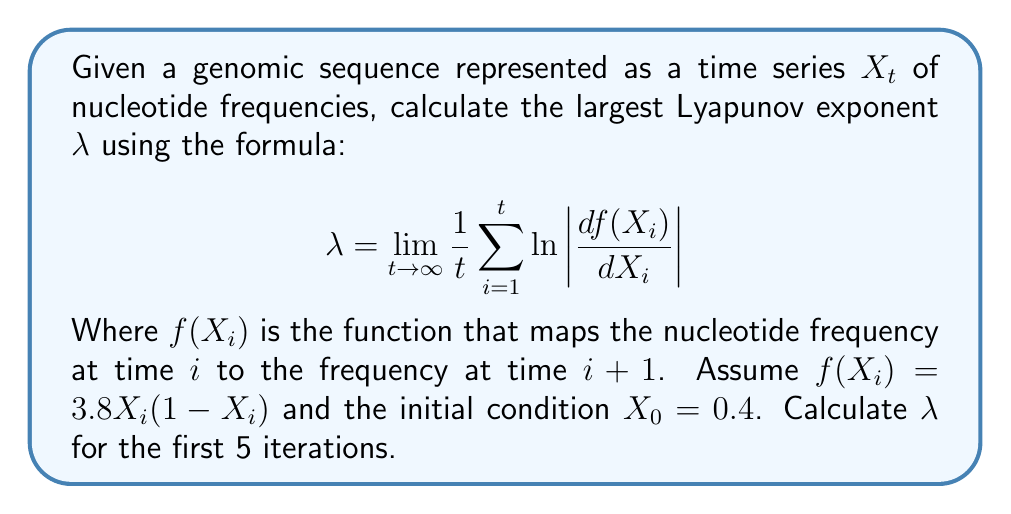Can you solve this math problem? To calculate the largest Lyapunov exponent $\lambda$ for the given genomic sequence data, we'll follow these steps:

1) First, we need to calculate $X_i$ for $i = 1$ to $5$ using the given function $f(X_i) = 3.8X_i(1-X_i)$ and initial condition $X_0 = 0.4$:

   $X_1 = f(X_0) = 3.8 \cdot 0.4 \cdot (1-0.4) = 0.912$
   $X_2 = f(X_1) = 3.8 \cdot 0.912 \cdot (1-0.912) = 0.305472$
   $X_3 = f(X_2) = 3.8 \cdot 0.305472 \cdot (1-0.305472) = 0.806219$
   $X_4 = f(X_3) = 3.8 \cdot 0.806219 \cdot (1-0.806219) = 0.595339$
   $X_5 = f(X_4) = 3.8 \cdot 0.595339 \cdot (1-0.595339) = 0.916291$

2) Next, we need to calculate $\frac{df(X_i)}{dX_i}$ for each $X_i$:

   $\frac{df(X)}{dX} = 3.8(1-2X)$

   For $X_0$: $\frac{df(X_0)}{dX_0} = 3.8(1-2\cdot0.4) = 0.76$
   For $X_1$: $\frac{df(X_1)}{dX_1} = 3.8(1-2\cdot0.912) = -3.1312$
   For $X_2$: $\frac{df(X_2)}{dX_2} = 3.8(1-2\cdot0.305472) = 1.47841$
   For $X_3$: $\frac{df(X_3)}{dX_3} = 3.8(1-2\cdot0.806219) = -2.32726$
   For $X_4$: $\frac{df(X_4)}{dX_4} = 3.8(1-2\cdot0.595339) = -0.724574$

3) Now, we can calculate $\ln \left|\frac{df(X_i)}{dX_i}\right|$ for each iteration:

   $\ln |0.76| = -0.274437$
   $\ln |-3.1312| = 1.141473$
   $\ln |1.47841| = 0.390837$
   $\ln |-2.32726| = 0.844839$
   $\ln |-0.724574| = -0.322136$

4) Finally, we can calculate $\lambda$ using the formula:

   $$\lambda \approx \frac{1}{5} (-0.274437 + 1.141473 + 0.390837 + 0.844839 - 0.322136)$$

   $$\lambda \approx \frac{1.780576}{5} = 0.356115$$

This positive Lyapunov exponent indicates chaotic behavior in the genetic sequence data.
Answer: $\lambda \approx 0.356115$ 